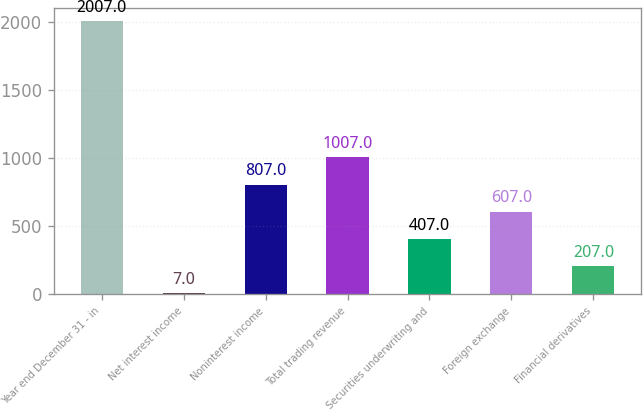Convert chart. <chart><loc_0><loc_0><loc_500><loc_500><bar_chart><fcel>Year end December 31 - in<fcel>Net interest income<fcel>Noninterest income<fcel>Total trading revenue<fcel>Securities underwriting and<fcel>Foreign exchange<fcel>Financial derivatives<nl><fcel>2007<fcel>7<fcel>807<fcel>1007<fcel>407<fcel>607<fcel>207<nl></chart> 